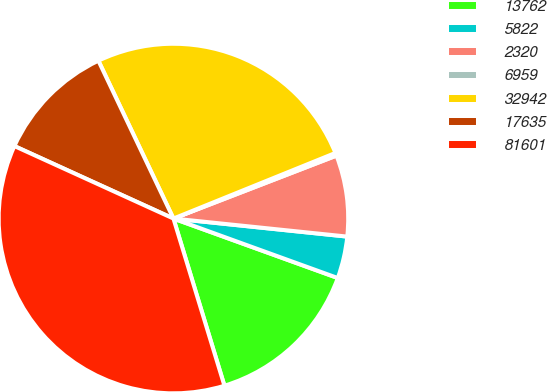Convert chart. <chart><loc_0><loc_0><loc_500><loc_500><pie_chart><fcel>13762<fcel>5822<fcel>2320<fcel>6959<fcel>32942<fcel>17635<fcel>81601<nl><fcel>14.76%<fcel>3.88%<fcel>7.51%<fcel>0.26%<fcel>25.94%<fcel>11.13%<fcel>36.52%<nl></chart> 